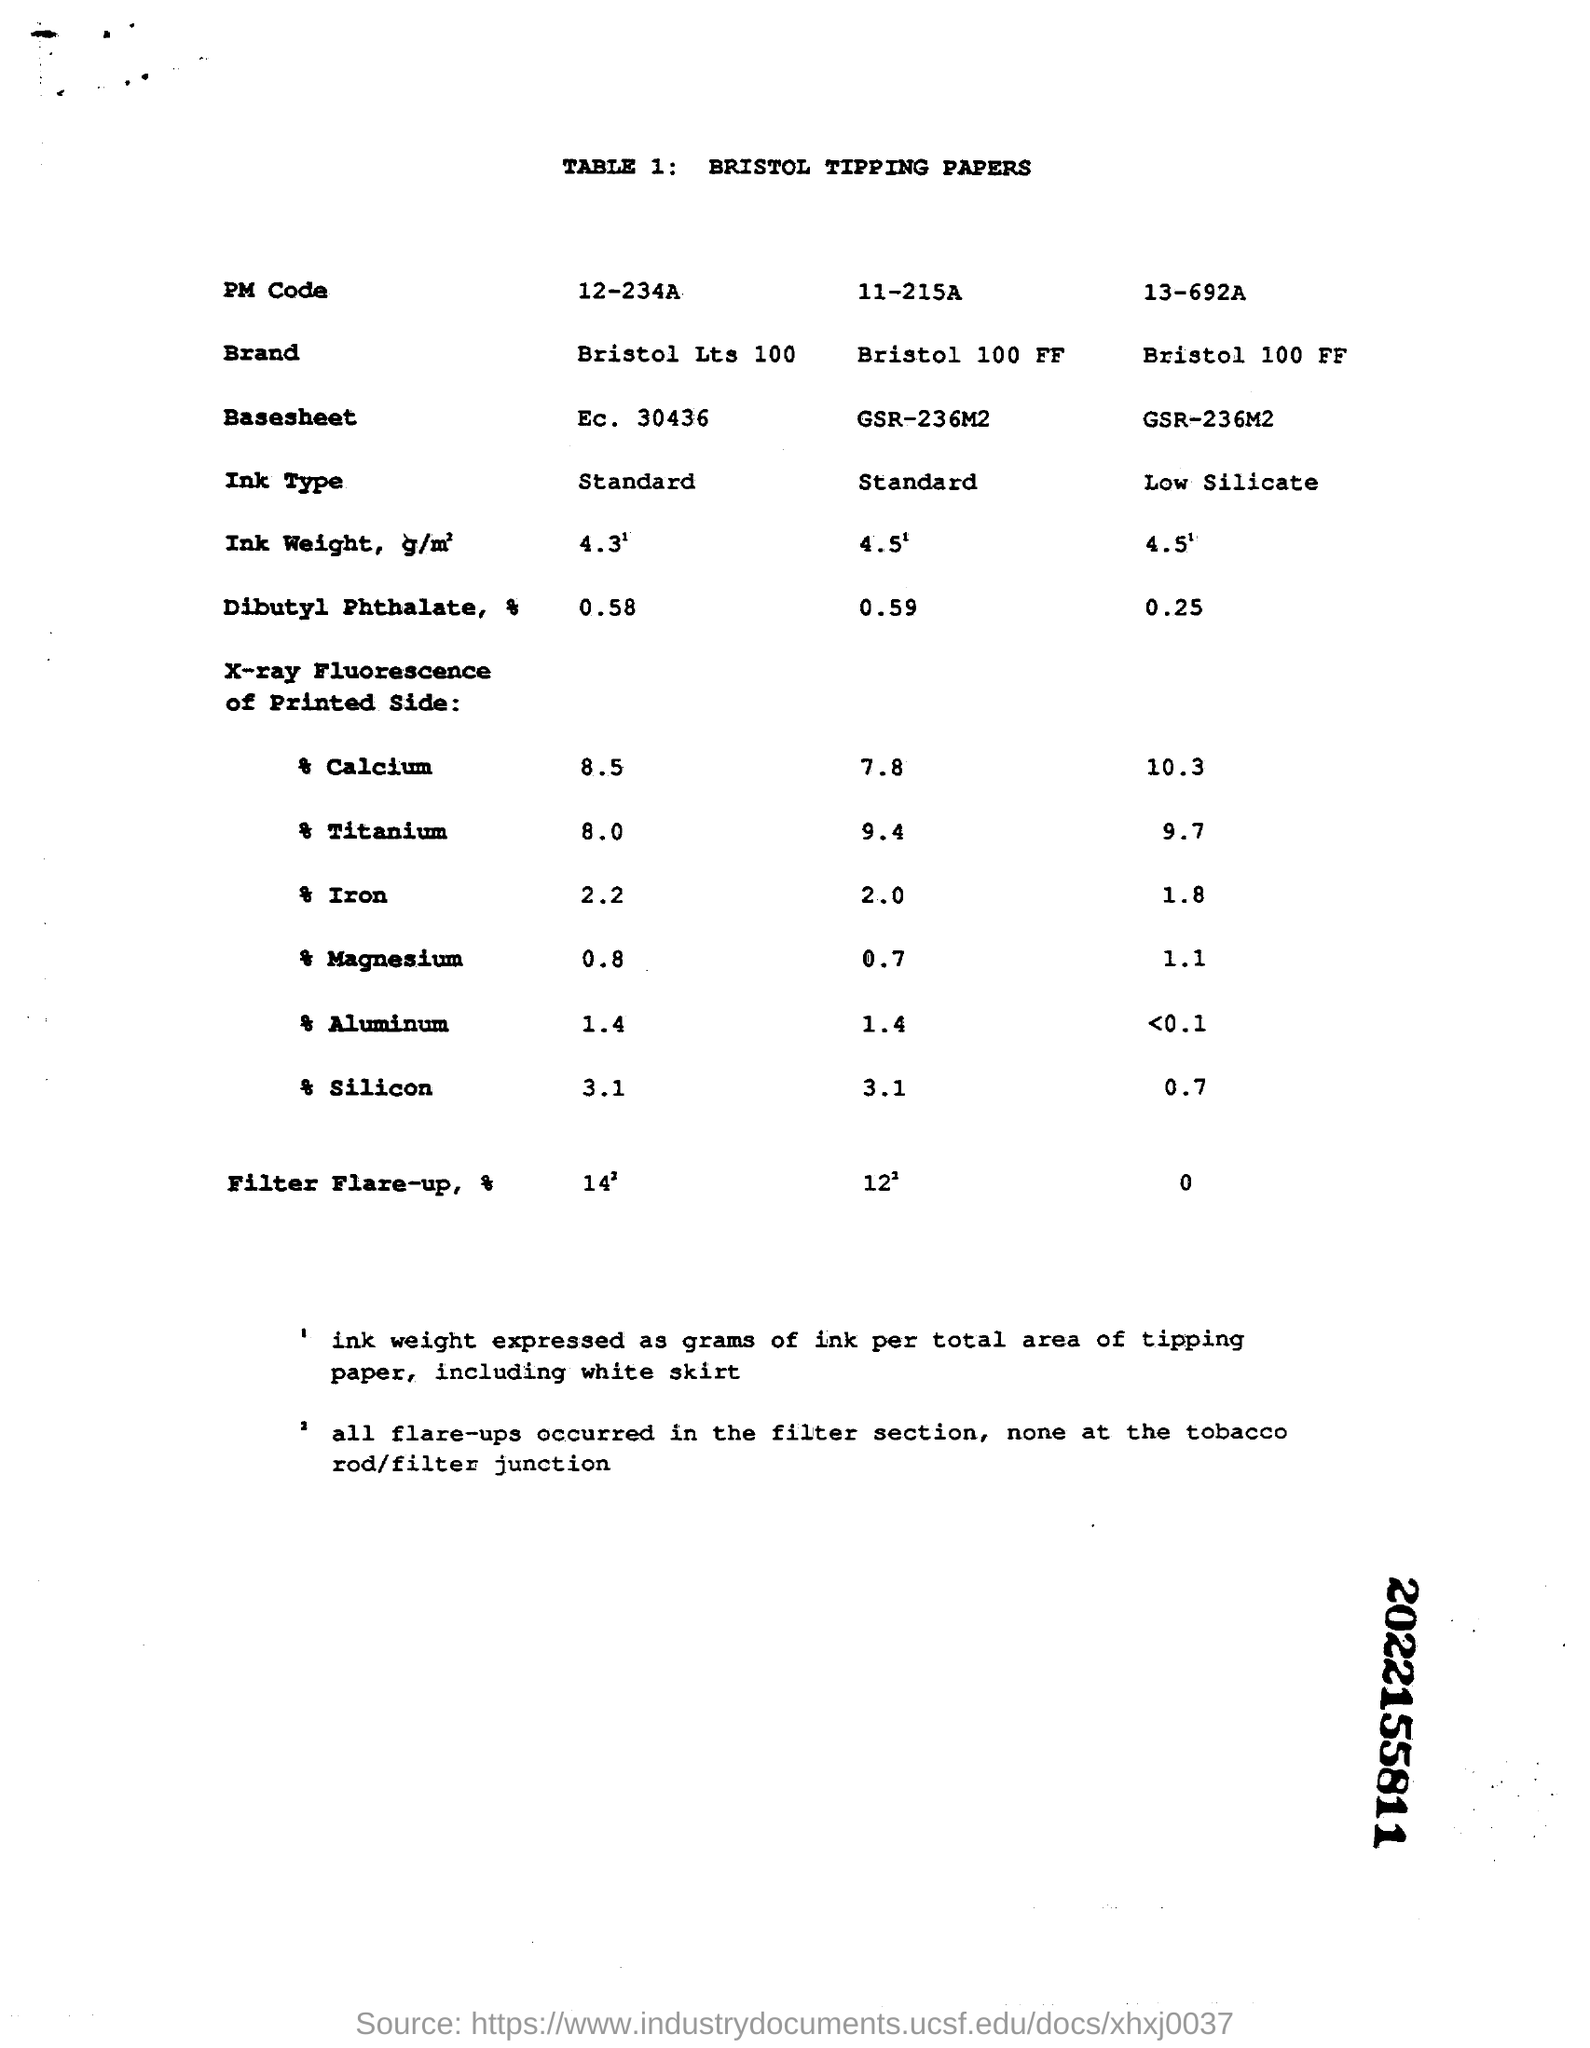Highlight a few significant elements in this photo. The value of "Titanium" entered in the second column under "X-ray Fluorescence of Printed side:" is 9.4. The value of "silicon" entered in the second column under "X-ray Fluorescence of Printed side" is 3.1. The brand mentioned in the third column of TABLE 1 is Bristol 100 FF. The value of "Magnesium" that was entered in the third column under "X-ray Fluorescence of Printed side" is 1.1. The "Ink Type" mentioned in the first column of "TABLE 1" is specified as "Standard. 